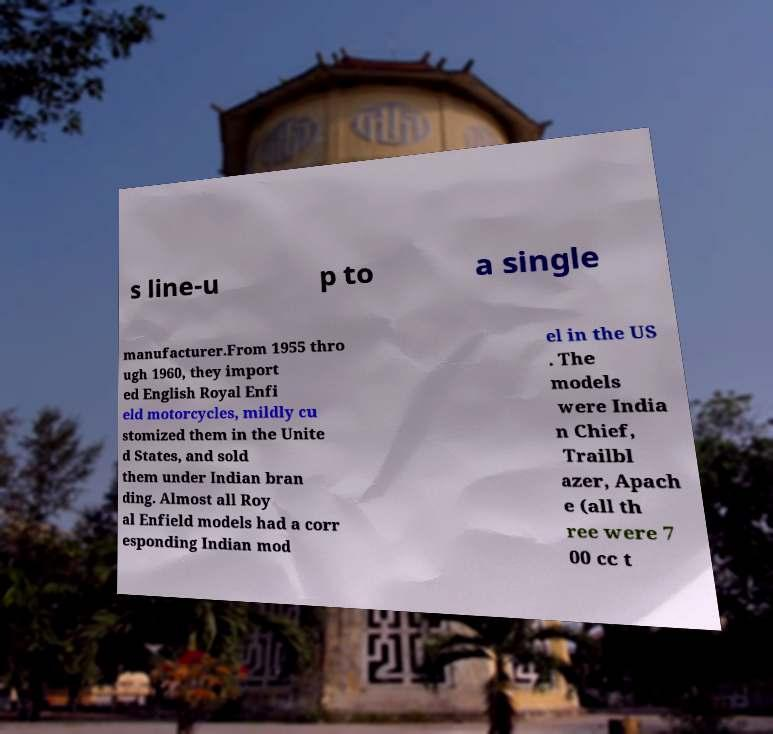Please read and relay the text visible in this image. What does it say? s line-u p to a single manufacturer.From 1955 thro ugh 1960, they import ed English Royal Enfi eld motorcycles, mildly cu stomized them in the Unite d States, and sold them under Indian bran ding. Almost all Roy al Enfield models had a corr esponding Indian mod el in the US . The models were India n Chief, Trailbl azer, Apach e (all th ree were 7 00 cc t 